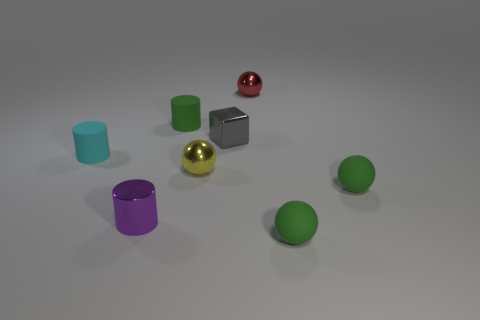Are there the same number of gray metal things that are behind the small gray thing and purple cylinders?
Your response must be concise. No. There is another shiny thing that is the same shape as the small red object; what color is it?
Your answer should be very brief. Yellow. Do the green thing that is on the left side of the small yellow shiny object and the purple thing have the same material?
Your answer should be compact. No. How many small objects are either metallic cylinders or balls?
Keep it short and to the point. 5. How big is the purple cylinder?
Ensure brevity in your answer.  Small. What number of cyan objects are either tiny matte things or small metallic things?
Keep it short and to the point. 1. How many tiny objects are there?
Ensure brevity in your answer.  8. How big is the purple shiny object that is in front of the yellow shiny ball?
Offer a terse response. Small. What number of things are small gray objects or tiny green spheres that are in front of the yellow ball?
Offer a terse response. 3. What is the yellow object made of?
Provide a short and direct response. Metal. 